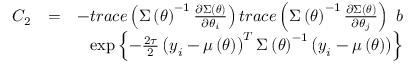<formula> <loc_0><loc_0><loc_500><loc_500>\begin{array} { r l r } { C _ { 2 } } & { = } & { - t r a c e \left ( \Sigma \left ( \theta \right ) ^ { - 1 } \frac { \partial \Sigma \left ( \theta \right ) } { \partial \theta _ { i } } \right ) t r a c e \left ( \Sigma \left ( \theta \right ) ^ { - 1 } \frac { \partial \Sigma \left ( \theta \right ) } { \partial \theta _ { j } } \right ) b } \\ & { \exp \left \{ - \frac { 2 \tau } { 2 } \left ( y _ { i } - \mu \left ( \theta \right ) \right ) ^ { T } \Sigma \left ( \theta \right ) ^ { - 1 } \left ( y _ { i } - \mu \left ( \theta \right ) \right ) \right \} } \end{array}</formula> 